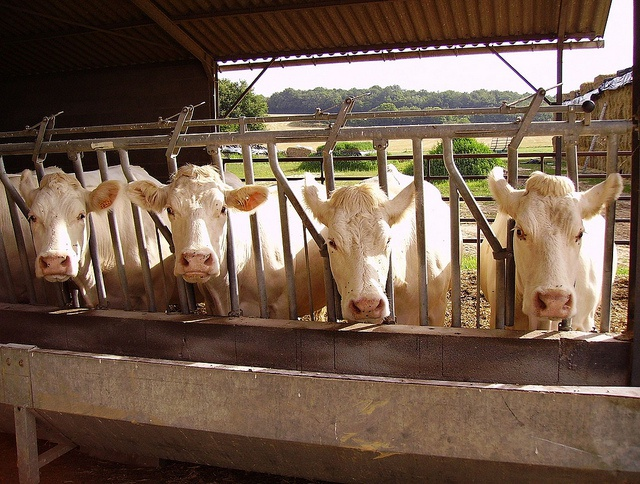Describe the objects in this image and their specific colors. I can see cow in black, white, tan, and gray tones, cow in black, tan, gray, and white tones, cow in black, white, gray, tan, and maroon tones, cow in black, gray, tan, and maroon tones, and cow in black, maroon, and tan tones in this image. 